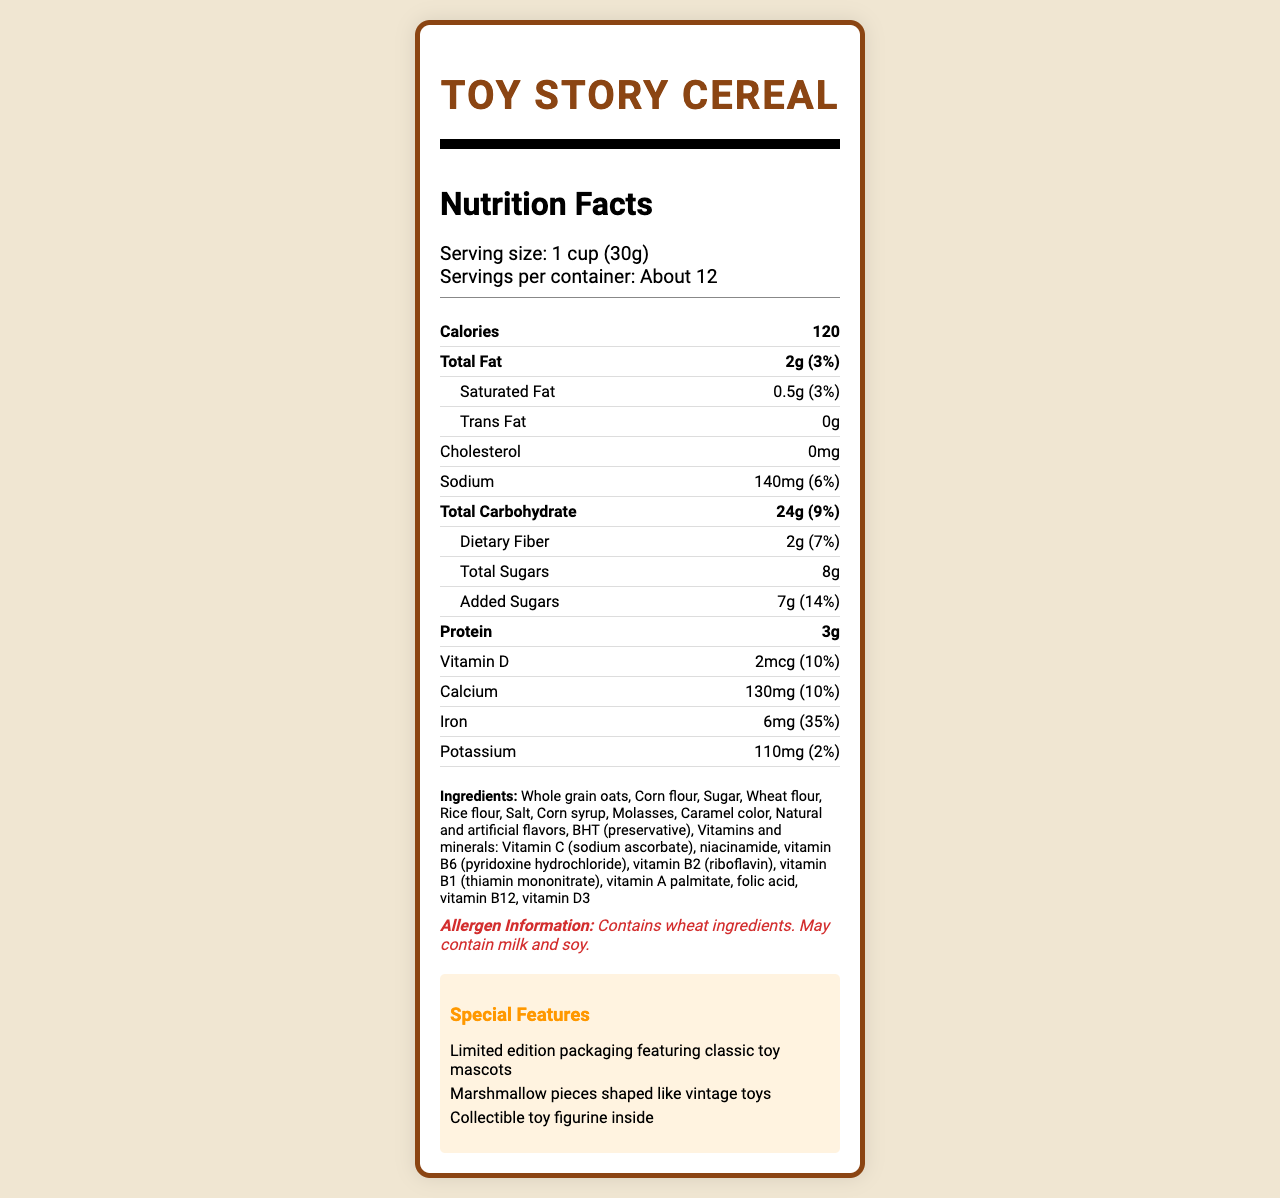what is the serving size? The serving size is explicitly mentioned at the beginning of the Nutrition Facts section.
Answer: 1 cup (30g) how many servings are in the container? The document specifies that there are about 12 servings per container.
Answer: About 12 what is the amount of total fat per serving? The amount of total fat is listed under the section for total fat.
Answer: 2g how much added sugar is in each serving? The amount of added sugars is stated explicitly in the document.
Answer: 7g how much protein does a serving contain? The protein content is listed under the major nutrient categories.
Answer: 3g how many calories are in one serving? The number of calories per serving is one of the major information points listed.
Answer: 120 how much dietary fiber does each serving provide? The dietary fiber amount is listed under the total carbohydrate section.
Answer: 2g when captured in a vintage toy dump truck, what is this a serving suggestion for? The photography notes suggest capturing the cereal in a vintage toy dump truck for a serving suggestion.
Answer: Toy Story Cereal what is the percentage of daily value for iron? The percentage of the daily value for iron is specified under the iron nutrient.
Answer: 35% which company manufactures this cereal? The manufacturer's name is mentioned at the end of the document.
Answer: Retro Toy Foods, Inc. how are the marshmallow pieces shaped? The special features section mentions that the marshmallow pieces are shaped like vintage toys.
Answer: Shaped like vintage toys does this cereal contain any trans fat? The document states that there is 0g of trans fat per serving.
Answer: No which of the following is a special feature of this cereal? A. Fortified with vitamin C B. Includes marshmallow pieces shaped like vintage toys C. Contains chocolate pieces The special features section mentions marshmallow pieces shaped like vintage toys.
Answer: B the primary ingredient in this cereal is: A. Corn flour B. Sugar C. Whole grain oats D. Wheat flour Whole grain oats are listed first in the ingredients, indicating they are the primary ingredient.
Answer: C how much sodium is in one serving? The sodium content is explicitly listed in the nutrient facts.
Answer: 140mg does this cereal contain any wheat ingredients? The allergen information clearly states that the cereal contains wheat.
Answer: Yes describe what the document is about. This summary encapsulates all the key elements described in the label, providing a comprehensive overview.
Answer: The document is a detailed nutrition facts label for a limited edition cereal called Toy Story Cereal. It includes information on serving size, calories, major nutrients, ingredients, allergen information, and special features, like collectible toy figurines and vintage toy-themed marshmallow pieces. Additionally, it provides notes for photographers capturing the cereal in creative and nostalgic contexts. can you determine the exact amount of vitamin C in each serving? The document does not specify the amount of vitamin C; it only mentions that it contains vitamins and minerals, including vitamin C.
Answer: Not enough information 